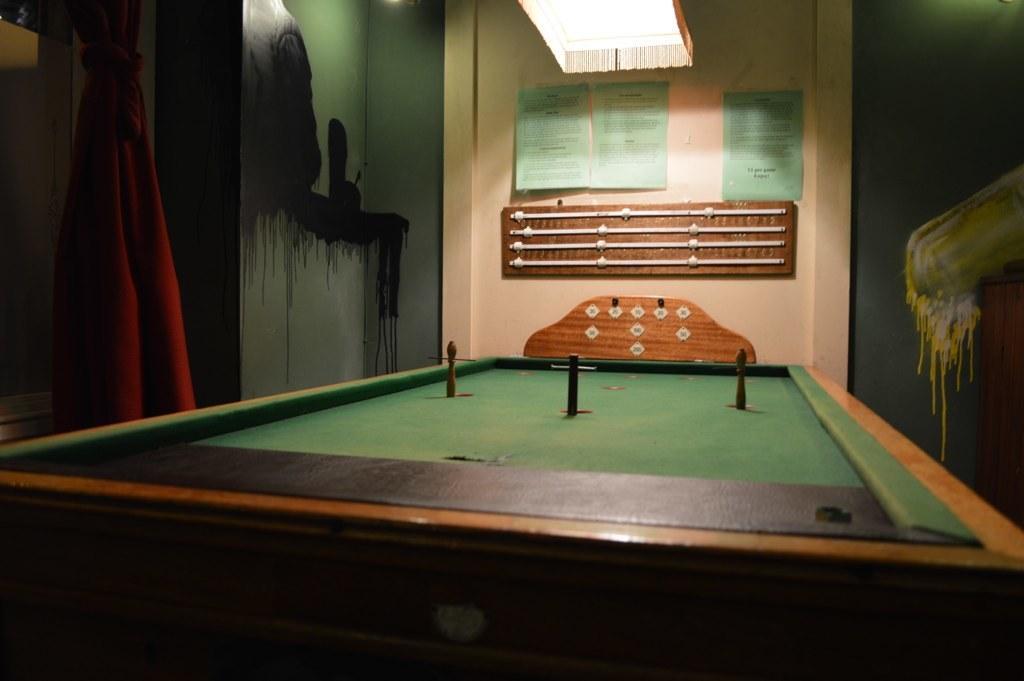Could you give a brief overview of what you see in this image? In the given image we can see a table. 